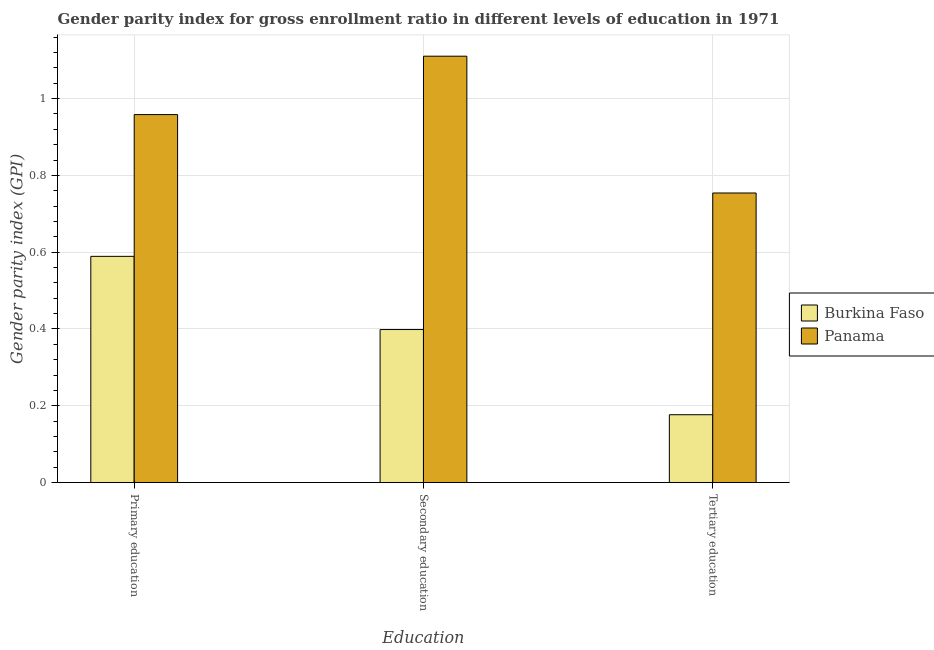How many groups of bars are there?
Your answer should be very brief. 3. How many bars are there on the 2nd tick from the right?
Your answer should be compact. 2. What is the label of the 3rd group of bars from the left?
Make the answer very short. Tertiary education. What is the gender parity index in secondary education in Panama?
Keep it short and to the point. 1.11. Across all countries, what is the maximum gender parity index in tertiary education?
Ensure brevity in your answer.  0.75. Across all countries, what is the minimum gender parity index in primary education?
Ensure brevity in your answer.  0.59. In which country was the gender parity index in tertiary education maximum?
Keep it short and to the point. Panama. In which country was the gender parity index in secondary education minimum?
Provide a succinct answer. Burkina Faso. What is the total gender parity index in tertiary education in the graph?
Offer a terse response. 0.93. What is the difference between the gender parity index in secondary education in Panama and that in Burkina Faso?
Offer a terse response. 0.71. What is the difference between the gender parity index in secondary education in Burkina Faso and the gender parity index in primary education in Panama?
Your answer should be compact. -0.56. What is the average gender parity index in tertiary education per country?
Offer a very short reply. 0.47. What is the difference between the gender parity index in tertiary education and gender parity index in secondary education in Panama?
Your answer should be very brief. -0.36. What is the ratio of the gender parity index in secondary education in Panama to that in Burkina Faso?
Keep it short and to the point. 2.79. Is the difference between the gender parity index in secondary education in Burkina Faso and Panama greater than the difference between the gender parity index in primary education in Burkina Faso and Panama?
Offer a terse response. No. What is the difference between the highest and the second highest gender parity index in secondary education?
Provide a short and direct response. 0.71. What is the difference between the highest and the lowest gender parity index in secondary education?
Ensure brevity in your answer.  0.71. In how many countries, is the gender parity index in tertiary education greater than the average gender parity index in tertiary education taken over all countries?
Offer a terse response. 1. Is the sum of the gender parity index in tertiary education in Burkina Faso and Panama greater than the maximum gender parity index in primary education across all countries?
Provide a short and direct response. No. What does the 2nd bar from the left in Primary education represents?
Provide a succinct answer. Panama. What does the 1st bar from the right in Secondary education represents?
Keep it short and to the point. Panama. Is it the case that in every country, the sum of the gender parity index in primary education and gender parity index in secondary education is greater than the gender parity index in tertiary education?
Your answer should be very brief. Yes. How many countries are there in the graph?
Provide a short and direct response. 2. What is the difference between two consecutive major ticks on the Y-axis?
Offer a terse response. 0.2. Does the graph contain grids?
Make the answer very short. Yes. Where does the legend appear in the graph?
Your answer should be compact. Center right. What is the title of the graph?
Offer a very short reply. Gender parity index for gross enrollment ratio in different levels of education in 1971. What is the label or title of the X-axis?
Offer a very short reply. Education. What is the label or title of the Y-axis?
Give a very brief answer. Gender parity index (GPI). What is the Gender parity index (GPI) of Burkina Faso in Primary education?
Your answer should be compact. 0.59. What is the Gender parity index (GPI) in Panama in Primary education?
Provide a short and direct response. 0.96. What is the Gender parity index (GPI) of Burkina Faso in Secondary education?
Provide a short and direct response. 0.4. What is the Gender parity index (GPI) in Panama in Secondary education?
Offer a terse response. 1.11. What is the Gender parity index (GPI) of Burkina Faso in Tertiary education?
Give a very brief answer. 0.18. What is the Gender parity index (GPI) in Panama in Tertiary education?
Offer a very short reply. 0.75. Across all Education, what is the maximum Gender parity index (GPI) in Burkina Faso?
Provide a short and direct response. 0.59. Across all Education, what is the maximum Gender parity index (GPI) in Panama?
Keep it short and to the point. 1.11. Across all Education, what is the minimum Gender parity index (GPI) in Burkina Faso?
Your answer should be very brief. 0.18. Across all Education, what is the minimum Gender parity index (GPI) of Panama?
Your answer should be very brief. 0.75. What is the total Gender parity index (GPI) of Burkina Faso in the graph?
Offer a terse response. 1.16. What is the total Gender parity index (GPI) in Panama in the graph?
Give a very brief answer. 2.82. What is the difference between the Gender parity index (GPI) of Burkina Faso in Primary education and that in Secondary education?
Keep it short and to the point. 0.19. What is the difference between the Gender parity index (GPI) in Panama in Primary education and that in Secondary education?
Your answer should be compact. -0.15. What is the difference between the Gender parity index (GPI) in Burkina Faso in Primary education and that in Tertiary education?
Ensure brevity in your answer.  0.41. What is the difference between the Gender parity index (GPI) in Panama in Primary education and that in Tertiary education?
Make the answer very short. 0.2. What is the difference between the Gender parity index (GPI) in Burkina Faso in Secondary education and that in Tertiary education?
Your answer should be compact. 0.22. What is the difference between the Gender parity index (GPI) in Panama in Secondary education and that in Tertiary education?
Provide a short and direct response. 0.36. What is the difference between the Gender parity index (GPI) in Burkina Faso in Primary education and the Gender parity index (GPI) in Panama in Secondary education?
Offer a very short reply. -0.52. What is the difference between the Gender parity index (GPI) in Burkina Faso in Primary education and the Gender parity index (GPI) in Panama in Tertiary education?
Offer a very short reply. -0.17. What is the difference between the Gender parity index (GPI) in Burkina Faso in Secondary education and the Gender parity index (GPI) in Panama in Tertiary education?
Your response must be concise. -0.36. What is the average Gender parity index (GPI) of Burkina Faso per Education?
Provide a short and direct response. 0.39. What is the average Gender parity index (GPI) in Panama per Education?
Make the answer very short. 0.94. What is the difference between the Gender parity index (GPI) in Burkina Faso and Gender parity index (GPI) in Panama in Primary education?
Your response must be concise. -0.37. What is the difference between the Gender parity index (GPI) of Burkina Faso and Gender parity index (GPI) of Panama in Secondary education?
Make the answer very short. -0.71. What is the difference between the Gender parity index (GPI) in Burkina Faso and Gender parity index (GPI) in Panama in Tertiary education?
Offer a terse response. -0.58. What is the ratio of the Gender parity index (GPI) in Burkina Faso in Primary education to that in Secondary education?
Provide a short and direct response. 1.48. What is the ratio of the Gender parity index (GPI) of Panama in Primary education to that in Secondary education?
Give a very brief answer. 0.86. What is the ratio of the Gender parity index (GPI) of Burkina Faso in Primary education to that in Tertiary education?
Your response must be concise. 3.33. What is the ratio of the Gender parity index (GPI) in Panama in Primary education to that in Tertiary education?
Keep it short and to the point. 1.27. What is the ratio of the Gender parity index (GPI) of Burkina Faso in Secondary education to that in Tertiary education?
Your answer should be compact. 2.25. What is the ratio of the Gender parity index (GPI) in Panama in Secondary education to that in Tertiary education?
Keep it short and to the point. 1.47. What is the difference between the highest and the second highest Gender parity index (GPI) in Burkina Faso?
Provide a succinct answer. 0.19. What is the difference between the highest and the second highest Gender parity index (GPI) in Panama?
Your answer should be compact. 0.15. What is the difference between the highest and the lowest Gender parity index (GPI) in Burkina Faso?
Keep it short and to the point. 0.41. What is the difference between the highest and the lowest Gender parity index (GPI) in Panama?
Provide a short and direct response. 0.36. 